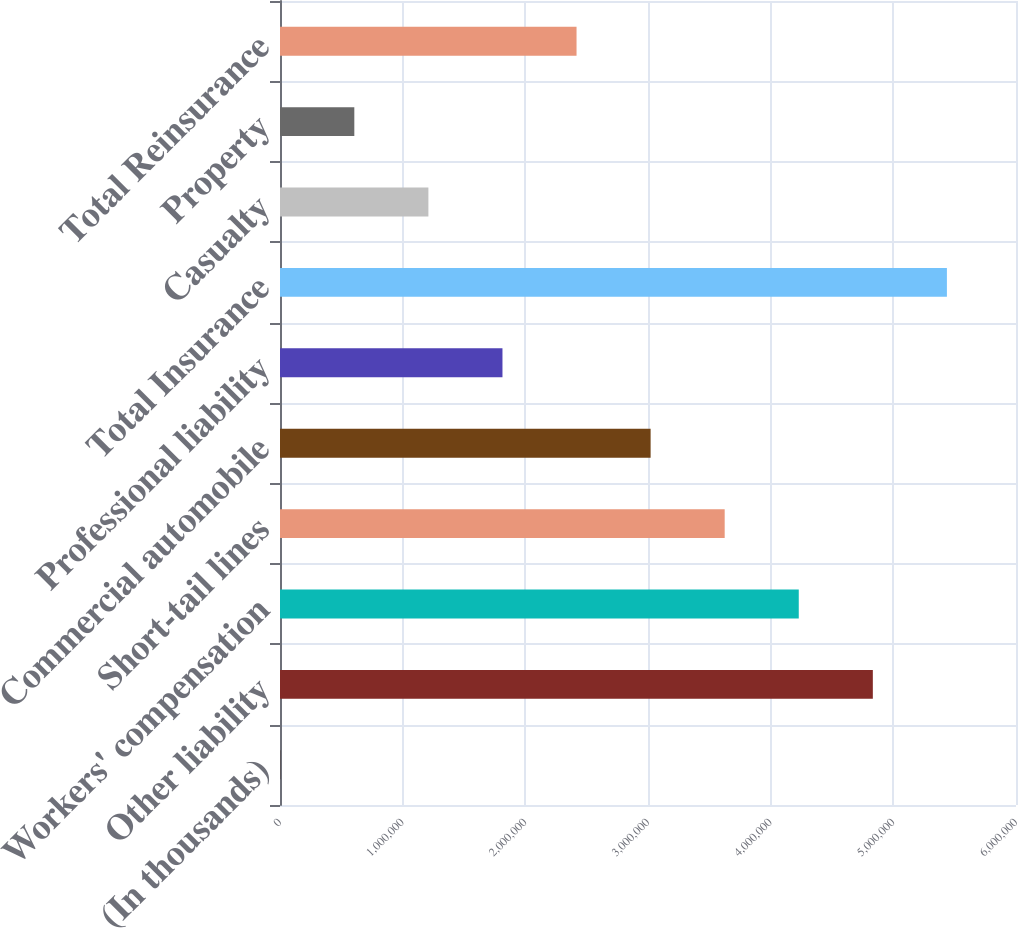Convert chart. <chart><loc_0><loc_0><loc_500><loc_500><bar_chart><fcel>(In thousands)<fcel>Other liability<fcel>Workers' compensation<fcel>Short-tail lines<fcel>Commercial automobile<fcel>Professional liability<fcel>Total Insurance<fcel>Casualty<fcel>Property<fcel>Total Reinsurance<nl><fcel>2015<fcel>4.83289e+06<fcel>4.22903e+06<fcel>3.62517e+06<fcel>3.02131e+06<fcel>1.81359e+06<fcel>5.43675e+06<fcel>1.20973e+06<fcel>605874<fcel>2.41745e+06<nl></chart> 